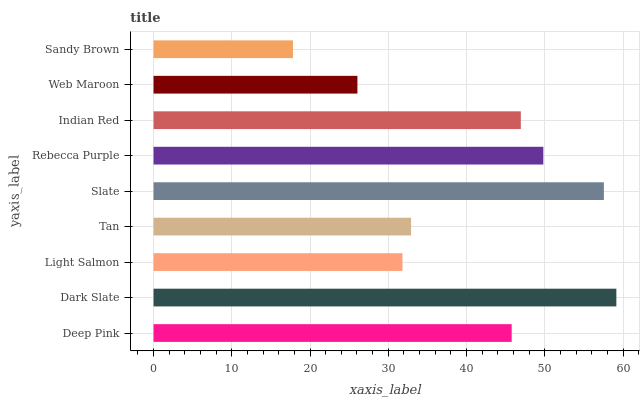Is Sandy Brown the minimum?
Answer yes or no. Yes. Is Dark Slate the maximum?
Answer yes or no. Yes. Is Light Salmon the minimum?
Answer yes or no. No. Is Light Salmon the maximum?
Answer yes or no. No. Is Dark Slate greater than Light Salmon?
Answer yes or no. Yes. Is Light Salmon less than Dark Slate?
Answer yes or no. Yes. Is Light Salmon greater than Dark Slate?
Answer yes or no. No. Is Dark Slate less than Light Salmon?
Answer yes or no. No. Is Deep Pink the high median?
Answer yes or no. Yes. Is Deep Pink the low median?
Answer yes or no. Yes. Is Indian Red the high median?
Answer yes or no. No. Is Web Maroon the low median?
Answer yes or no. No. 